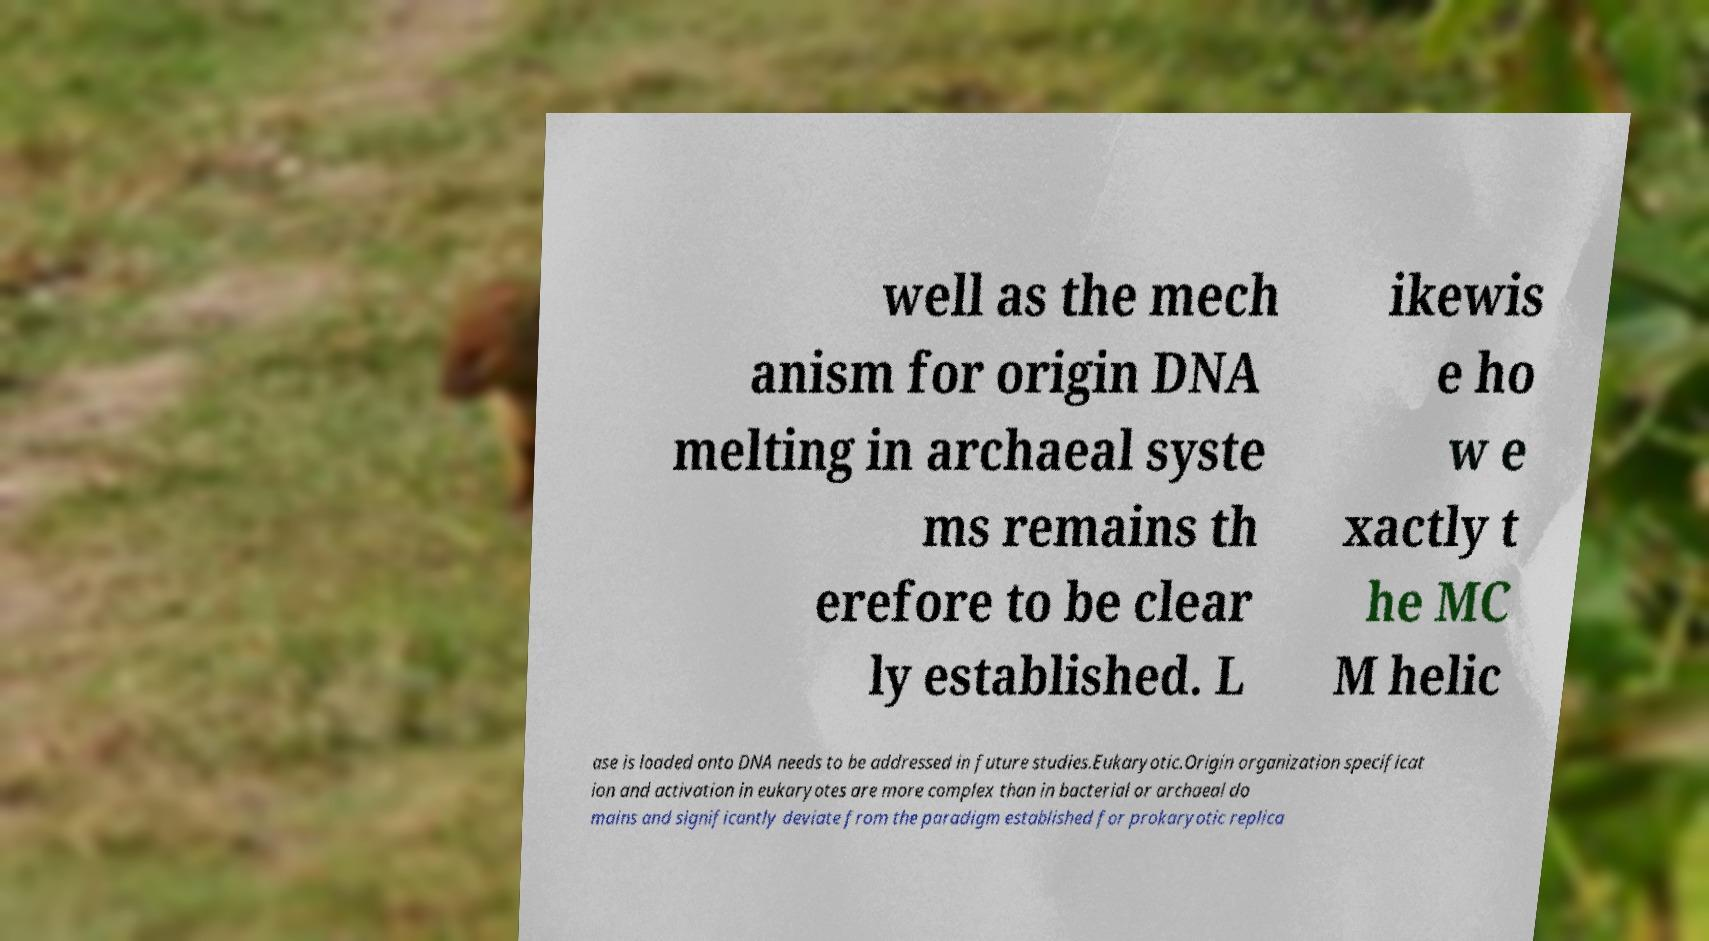What messages or text are displayed in this image? I need them in a readable, typed format. well as the mech anism for origin DNA melting in archaeal syste ms remains th erefore to be clear ly established. L ikewis e ho w e xactly t he MC M helic ase is loaded onto DNA needs to be addressed in future studies.Eukaryotic.Origin organization specificat ion and activation in eukaryotes are more complex than in bacterial or archaeal do mains and significantly deviate from the paradigm established for prokaryotic replica 